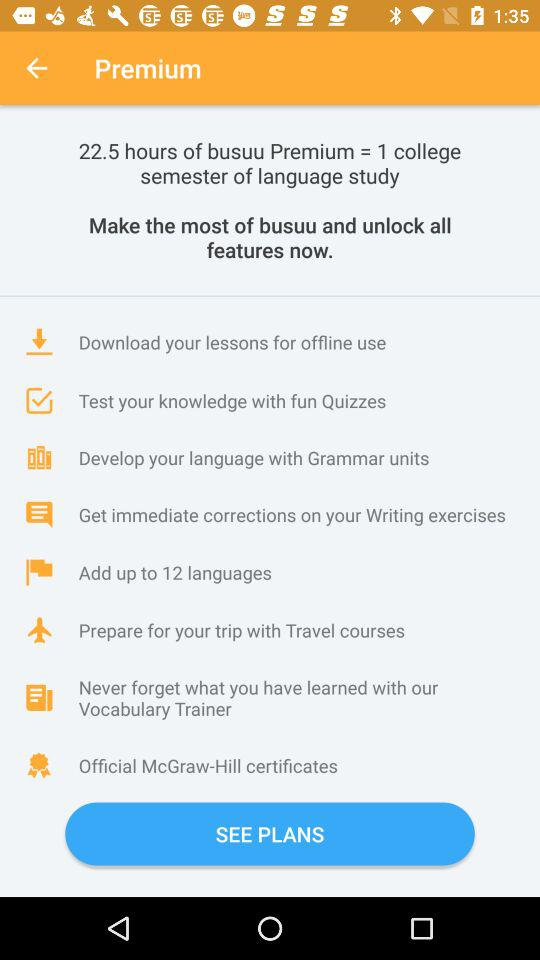How many hours of "busuu Premium = 1 college semester of language study"? There are 22.5 hours. 